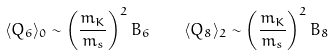<formula> <loc_0><loc_0><loc_500><loc_500>\langle Q _ { 6 } \rangle _ { 0 } \sim \left ( \frac { m _ { K } } { m _ { s } } \right ) ^ { 2 } B _ { 6 } \quad \langle Q _ { 8 } \rangle _ { 2 } \sim \left ( \frac { m _ { K } } { m _ { s } } \right ) ^ { 2 } B _ { 8 }</formula> 